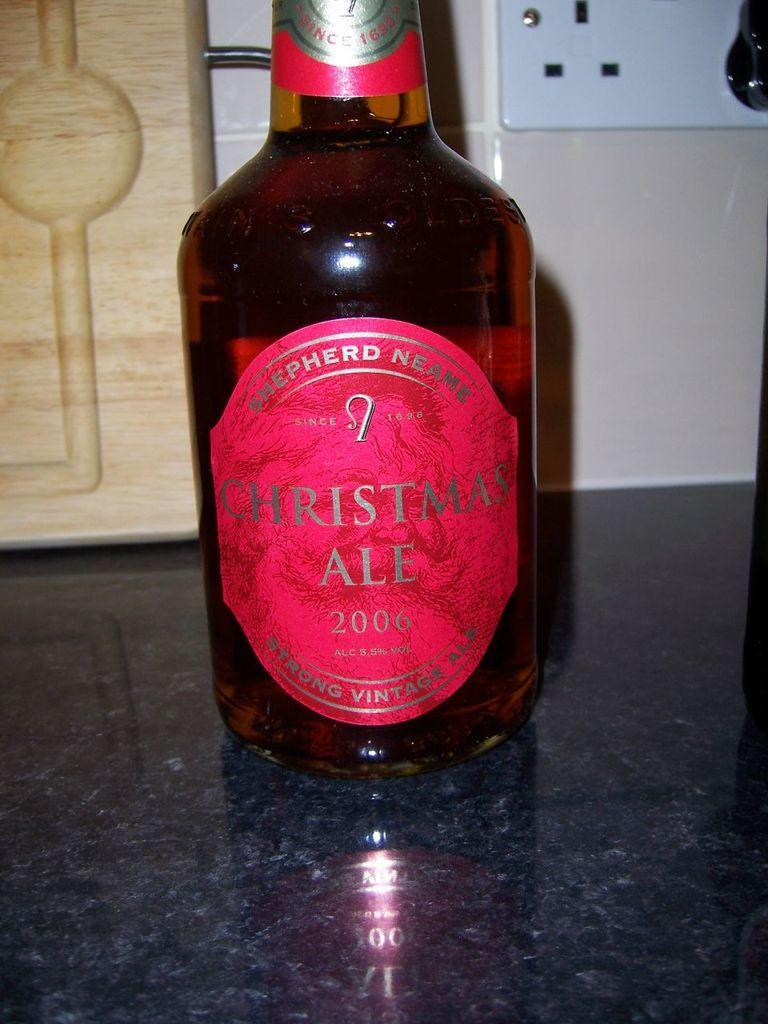<image>
Present a compact description of the photo's key features. christmas ale from 2006 is sitting on a table 